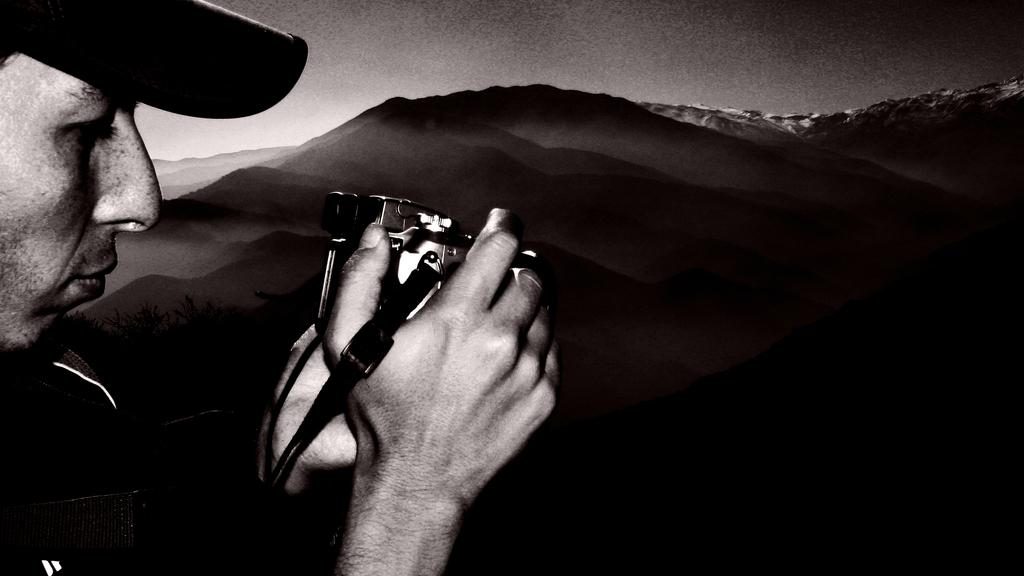Who is the main subject in the image? There is a man in the image. What is the man holding in the image? The man is holding a camera. What type of headwear is the man wearing? The man is wearing a cap. What is the color scheme of the image? The image is black and white in color. What advice does the man give to the team in the image? There is no team present in the image, nor is there any indication that the man is giving advice. 